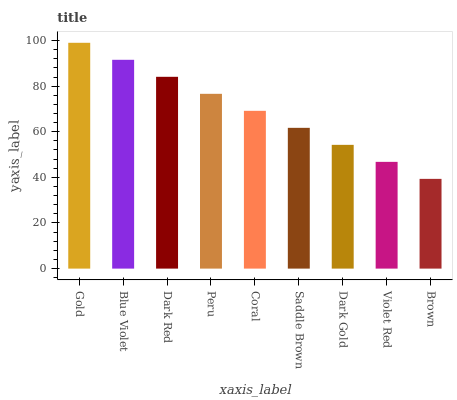Is Brown the minimum?
Answer yes or no. Yes. Is Gold the maximum?
Answer yes or no. Yes. Is Blue Violet the minimum?
Answer yes or no. No. Is Blue Violet the maximum?
Answer yes or no. No. Is Gold greater than Blue Violet?
Answer yes or no. Yes. Is Blue Violet less than Gold?
Answer yes or no. Yes. Is Blue Violet greater than Gold?
Answer yes or no. No. Is Gold less than Blue Violet?
Answer yes or no. No. Is Coral the high median?
Answer yes or no. Yes. Is Coral the low median?
Answer yes or no. Yes. Is Blue Violet the high median?
Answer yes or no. No. Is Brown the low median?
Answer yes or no. No. 